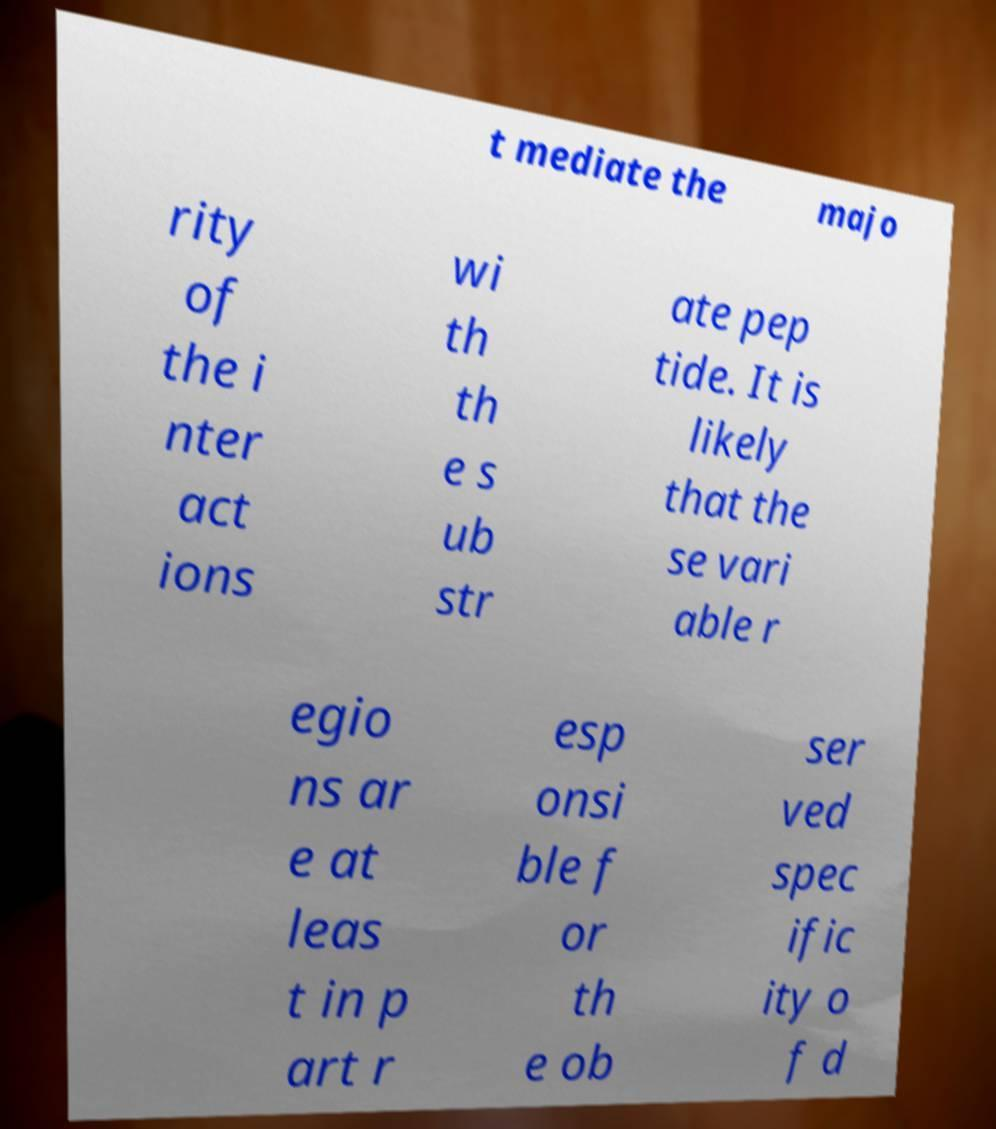Can you accurately transcribe the text from the provided image for me? t mediate the majo rity of the i nter act ions wi th th e s ub str ate pep tide. It is likely that the se vari able r egio ns ar e at leas t in p art r esp onsi ble f or th e ob ser ved spec ific ity o f d 